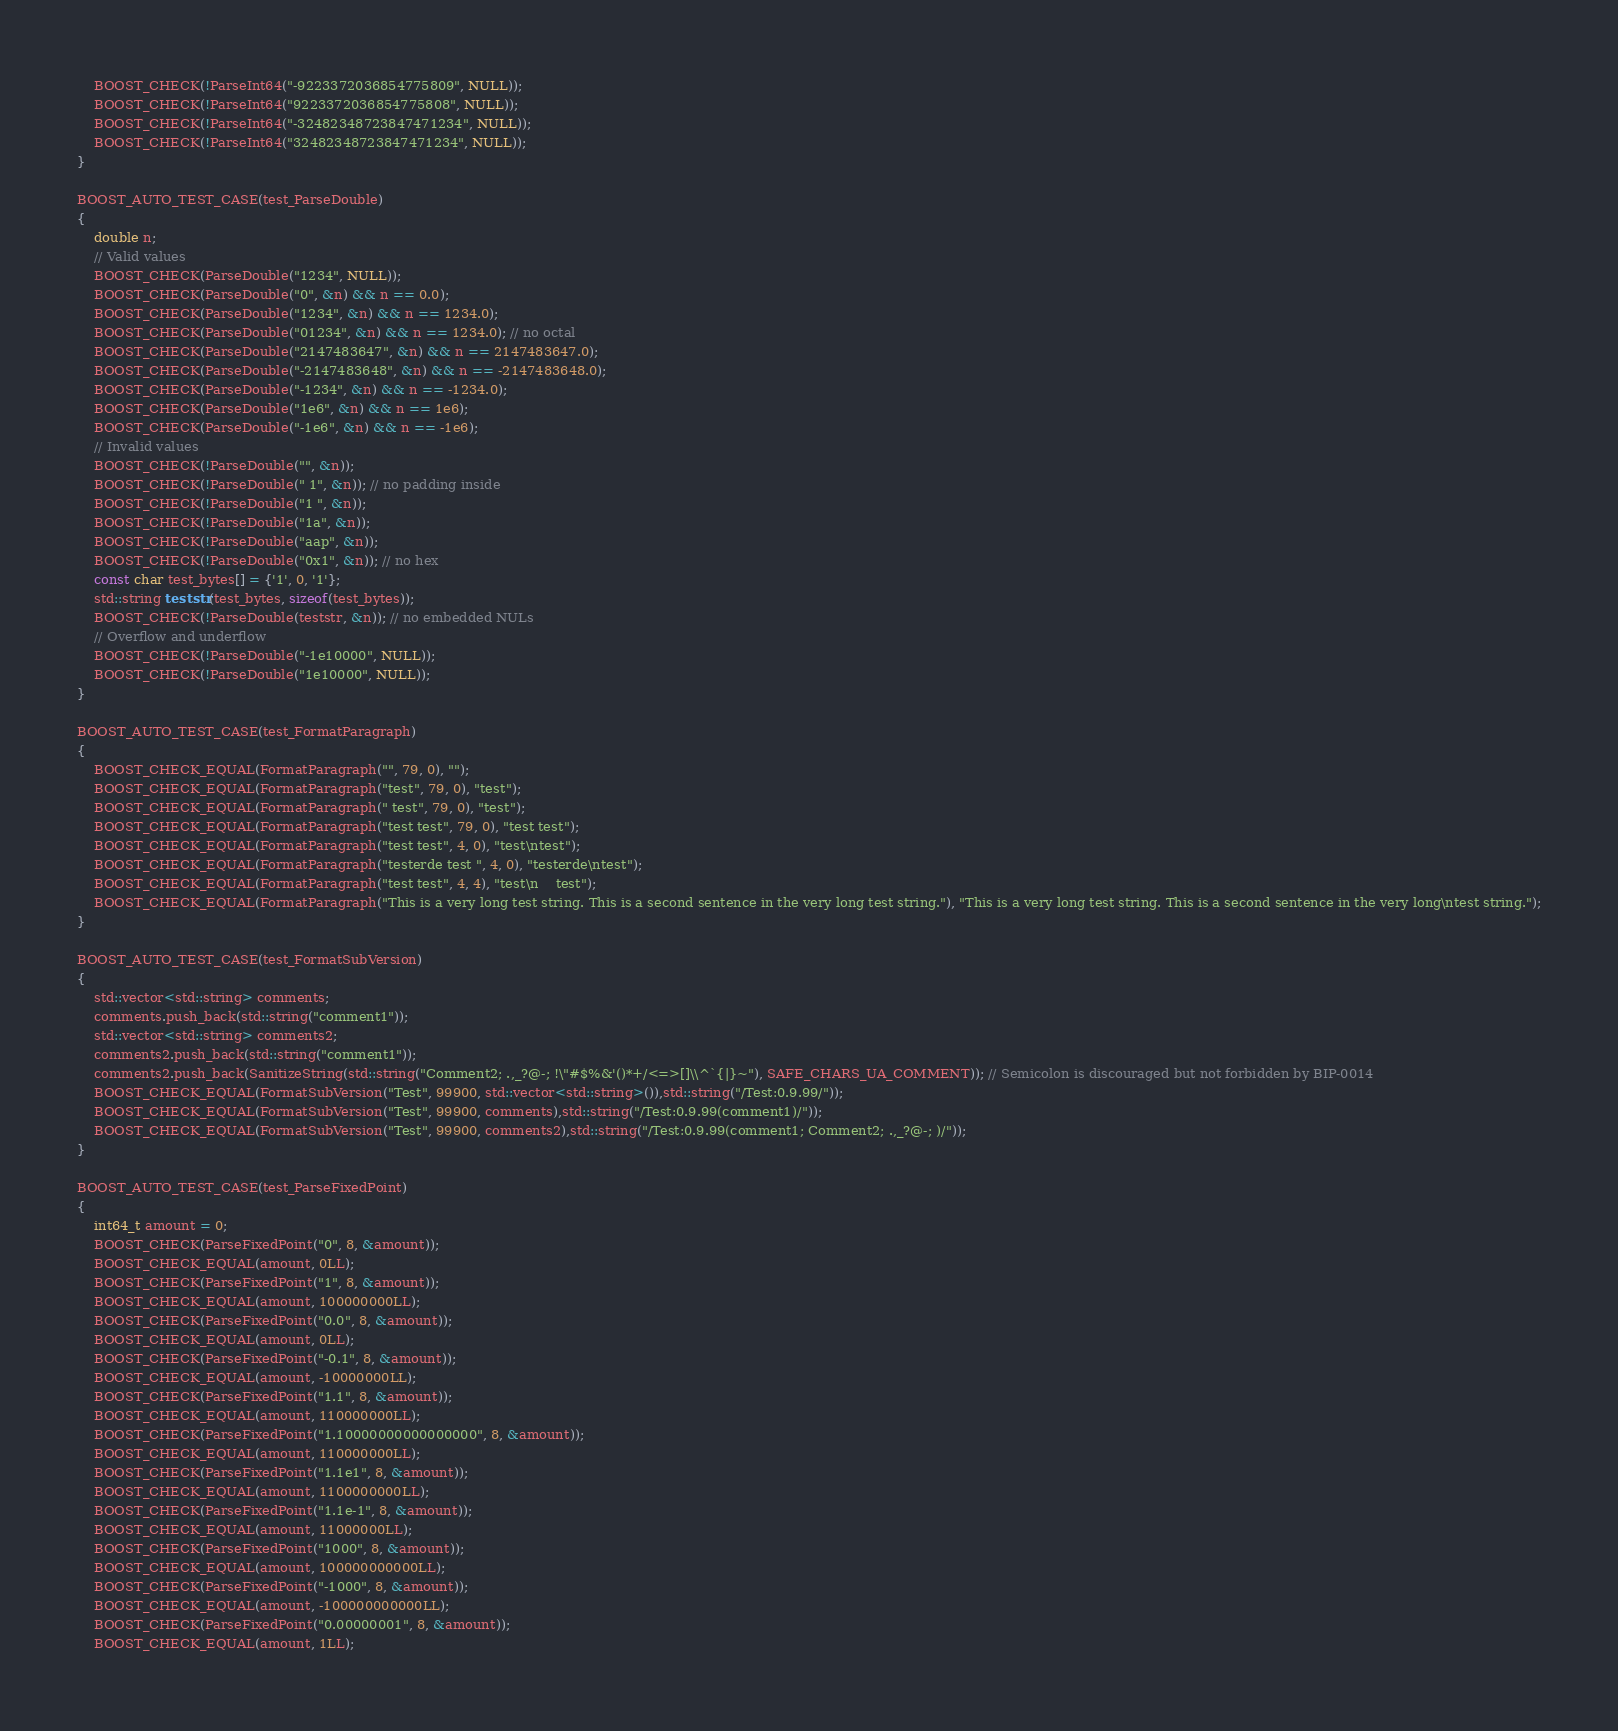Convert code to text. <code><loc_0><loc_0><loc_500><loc_500><_C++_>    BOOST_CHECK(!ParseInt64("-9223372036854775809", NULL));
    BOOST_CHECK(!ParseInt64("9223372036854775808", NULL));
    BOOST_CHECK(!ParseInt64("-32482348723847471234", NULL));
    BOOST_CHECK(!ParseInt64("32482348723847471234", NULL));
}

BOOST_AUTO_TEST_CASE(test_ParseDouble)
{
    double n;
    // Valid values
    BOOST_CHECK(ParseDouble("1234", NULL));
    BOOST_CHECK(ParseDouble("0", &n) && n == 0.0);
    BOOST_CHECK(ParseDouble("1234", &n) && n == 1234.0);
    BOOST_CHECK(ParseDouble("01234", &n) && n == 1234.0); // no octal
    BOOST_CHECK(ParseDouble("2147483647", &n) && n == 2147483647.0);
    BOOST_CHECK(ParseDouble("-2147483648", &n) && n == -2147483648.0);
    BOOST_CHECK(ParseDouble("-1234", &n) && n == -1234.0);
    BOOST_CHECK(ParseDouble("1e6", &n) && n == 1e6);
    BOOST_CHECK(ParseDouble("-1e6", &n) && n == -1e6);
    // Invalid values
    BOOST_CHECK(!ParseDouble("", &n));
    BOOST_CHECK(!ParseDouble(" 1", &n)); // no padding inside
    BOOST_CHECK(!ParseDouble("1 ", &n));
    BOOST_CHECK(!ParseDouble("1a", &n));
    BOOST_CHECK(!ParseDouble("aap", &n));
    BOOST_CHECK(!ParseDouble("0x1", &n)); // no hex
    const char test_bytes[] = {'1', 0, '1'};
    std::string teststr(test_bytes, sizeof(test_bytes));
    BOOST_CHECK(!ParseDouble(teststr, &n)); // no embedded NULs
    // Overflow and underflow
    BOOST_CHECK(!ParseDouble("-1e10000", NULL));
    BOOST_CHECK(!ParseDouble("1e10000", NULL));
}

BOOST_AUTO_TEST_CASE(test_FormatParagraph)
{
    BOOST_CHECK_EQUAL(FormatParagraph("", 79, 0), "");
    BOOST_CHECK_EQUAL(FormatParagraph("test", 79, 0), "test");
    BOOST_CHECK_EQUAL(FormatParagraph(" test", 79, 0), "test");
    BOOST_CHECK_EQUAL(FormatParagraph("test test", 79, 0), "test test");
    BOOST_CHECK_EQUAL(FormatParagraph("test test", 4, 0), "test\ntest");
    BOOST_CHECK_EQUAL(FormatParagraph("testerde test ", 4, 0), "testerde\ntest");
    BOOST_CHECK_EQUAL(FormatParagraph("test test", 4, 4), "test\n    test");
    BOOST_CHECK_EQUAL(FormatParagraph("This is a very long test string. This is a second sentence in the very long test string."), "This is a very long test string. This is a second sentence in the very long\ntest string.");
}

BOOST_AUTO_TEST_CASE(test_FormatSubVersion)
{
    std::vector<std::string> comments;
    comments.push_back(std::string("comment1"));
    std::vector<std::string> comments2;
    comments2.push_back(std::string("comment1"));
    comments2.push_back(SanitizeString(std::string("Comment2; .,_?@-; !\"#$%&'()*+/<=>[]\\^`{|}~"), SAFE_CHARS_UA_COMMENT)); // Semicolon is discouraged but not forbidden by BIP-0014
    BOOST_CHECK_EQUAL(FormatSubVersion("Test", 99900, std::vector<std::string>()),std::string("/Test:0.9.99/"));
    BOOST_CHECK_EQUAL(FormatSubVersion("Test", 99900, comments),std::string("/Test:0.9.99(comment1)/"));
    BOOST_CHECK_EQUAL(FormatSubVersion("Test", 99900, comments2),std::string("/Test:0.9.99(comment1; Comment2; .,_?@-; )/"));
}

BOOST_AUTO_TEST_CASE(test_ParseFixedPoint)
{
    int64_t amount = 0;
    BOOST_CHECK(ParseFixedPoint("0", 8, &amount));
    BOOST_CHECK_EQUAL(amount, 0LL);
    BOOST_CHECK(ParseFixedPoint("1", 8, &amount));
    BOOST_CHECK_EQUAL(amount, 100000000LL);
    BOOST_CHECK(ParseFixedPoint("0.0", 8, &amount));
    BOOST_CHECK_EQUAL(amount, 0LL);
    BOOST_CHECK(ParseFixedPoint("-0.1", 8, &amount));
    BOOST_CHECK_EQUAL(amount, -10000000LL);
    BOOST_CHECK(ParseFixedPoint("1.1", 8, &amount));
    BOOST_CHECK_EQUAL(amount, 110000000LL);
    BOOST_CHECK(ParseFixedPoint("1.10000000000000000", 8, &amount));
    BOOST_CHECK_EQUAL(amount, 110000000LL);
    BOOST_CHECK(ParseFixedPoint("1.1e1", 8, &amount));
    BOOST_CHECK_EQUAL(amount, 1100000000LL);
    BOOST_CHECK(ParseFixedPoint("1.1e-1", 8, &amount));
    BOOST_CHECK_EQUAL(amount, 11000000LL);
    BOOST_CHECK(ParseFixedPoint("1000", 8, &amount));
    BOOST_CHECK_EQUAL(amount, 100000000000LL);
    BOOST_CHECK(ParseFixedPoint("-1000", 8, &amount));
    BOOST_CHECK_EQUAL(amount, -100000000000LL);
    BOOST_CHECK(ParseFixedPoint("0.00000001", 8, &amount));
    BOOST_CHECK_EQUAL(amount, 1LL);</code> 